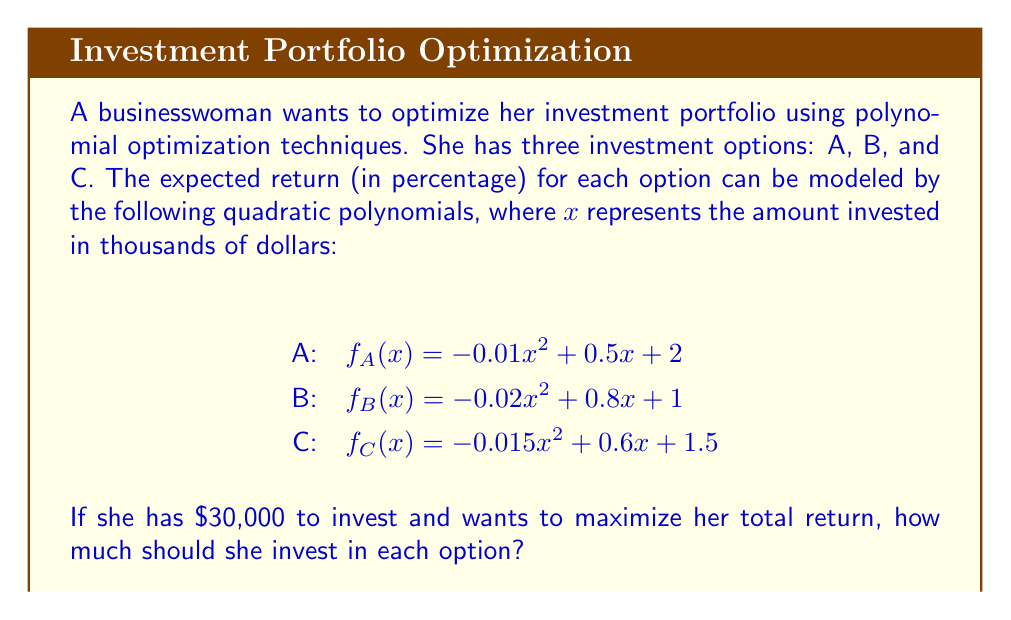What is the answer to this math problem? To solve this problem, we need to use polynomial optimization techniques. Let's approach this step-by-step:

1) Let $x$, $y$, and $z$ represent the amount invested in thousands of dollars for options A, B, and C respectively.

2) Our objective function (total return) is:
   $$f(x,y,z) = (-0.01x^2 + 0.5x + 2) + (-0.02y^2 + 0.8y + 1) + (-0.015z^2 + 0.6z + 1.5)$$

3) We have two constraints:
   a) $x + y + z = 30$ (total investment is $30,000)
   b) $x, y, z \geq 0$ (non-negative investments)

4) To maximize $f(x,y,z)$ subject to these constraints, we can use the method of Lagrange multipliers:
   $$L(x,y,z,\lambda) = f(x,y,z) - \lambda(x + y + z - 30)$$

5) Taking partial derivatives and setting them to zero:
   $$\frac{\partial L}{\partial x} = -0.02x + 0.5 - \lambda = 0$$
   $$\frac{\partial L}{\partial y} = -0.04y + 0.8 - \lambda = 0$$
   $$\frac{\partial L}{\partial z} = -0.03z + 0.6 - \lambda = 0$$
   $$\frac{\partial L}{\partial \lambda} = x + y + z - 30 = 0$$

6) From these equations:
   $x = 25 - 50\lambda$
   $y = 20 - 25\lambda$
   $z = 20 - \frac{100}{3}\lambda$

7) Substituting these into the constraint equation:
   $$(25 - 50\lambda) + (20 - 25\lambda) + (20 - \frac{100}{3}\lambda) = 30$$

8) Solving for $\lambda$:
   $$65 - \frac{275}{3}\lambda = 30$$
   $$\lambda = \frac{105}{275} = 0.3818$$

9) Substituting back:
   $x = 25 - 50(0.3818) = 5.91$
   $y = 20 - 25(0.3818) = 10.45$
   $z = 20 - \frac{100}{3}(0.3818) = 13.64$

10) Therefore, the optimal investment strategy is:
    Option A: $5,910
    Option B: $10,450
    Option C: $13,640
Answer: A: $5,910, B: $10,450, C: $13,640 